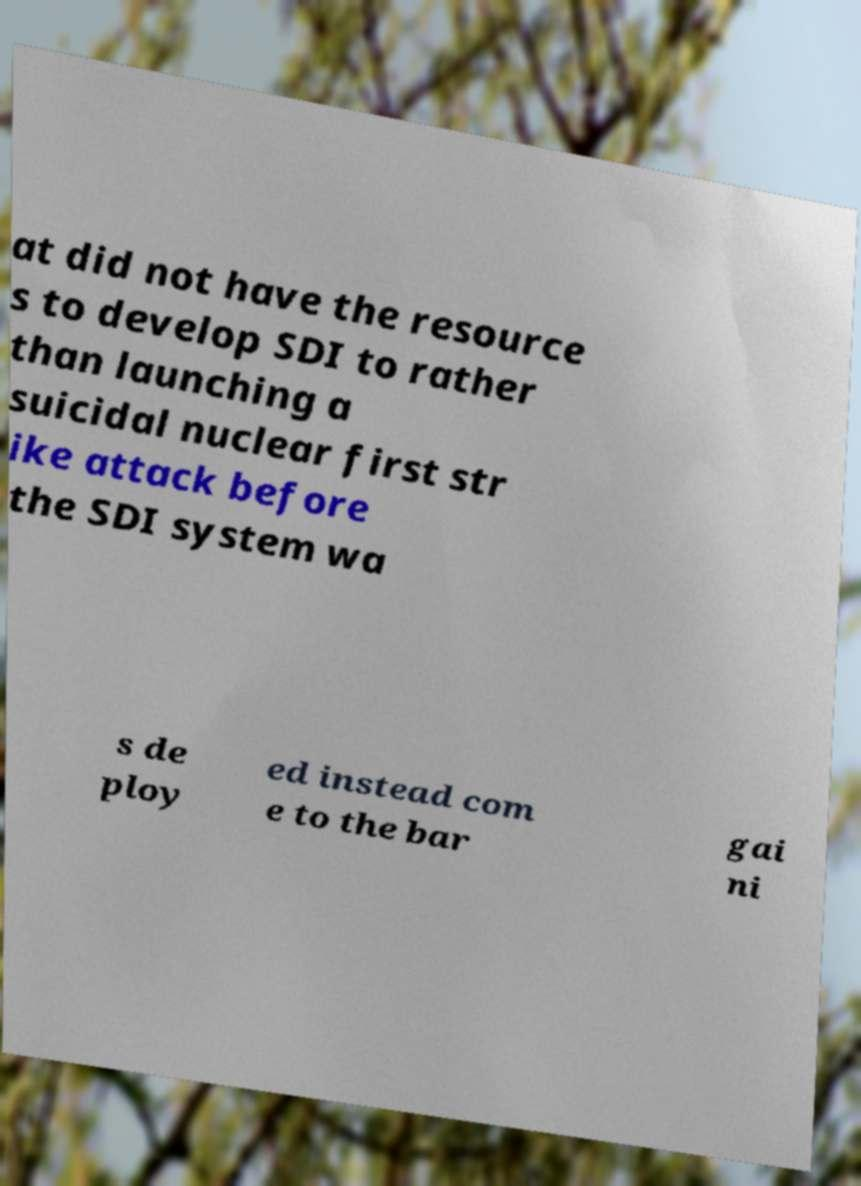I need the written content from this picture converted into text. Can you do that? at did not have the resource s to develop SDI to rather than launching a suicidal nuclear first str ike attack before the SDI system wa s de ploy ed instead com e to the bar gai ni 